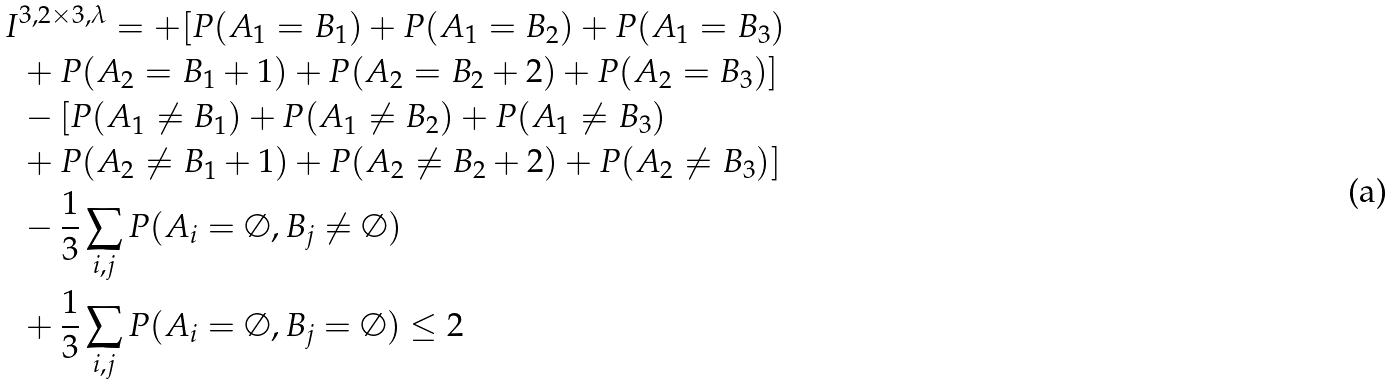Convert formula to latex. <formula><loc_0><loc_0><loc_500><loc_500>I & ^ { 3 , 2 \times 3 , \lambda } = + [ P ( A _ { 1 } = B _ { 1 } ) + P ( A _ { 1 } = B _ { 2 } ) + P ( A _ { 1 } = B _ { 3 } ) \\ & + P ( A _ { 2 } = B _ { 1 } + 1 ) + P ( A _ { 2 } = B _ { 2 } + 2 ) + P ( A _ { 2 } = B _ { 3 } ) ] \\ & - [ P ( A _ { 1 } \neq B _ { 1 } ) + P ( A _ { 1 } \neq B _ { 2 } ) + P ( A _ { 1 } \neq B _ { 3 } ) \\ & + P ( A _ { 2 } \neq B _ { 1 } + 1 ) + P ( A _ { 2 } \neq B _ { 2 } + 2 ) + P ( A _ { 2 } \neq B _ { 3 } ) ] \\ & - \frac { 1 } { 3 } \sum _ { i , j } P ( A _ { i } = \emptyset , B _ { j } \neq \emptyset ) \\ & + \frac { 1 } { 3 } \sum _ { i , j } P ( A _ { i } = \emptyset , B _ { j } = \emptyset ) \leq 2</formula> 